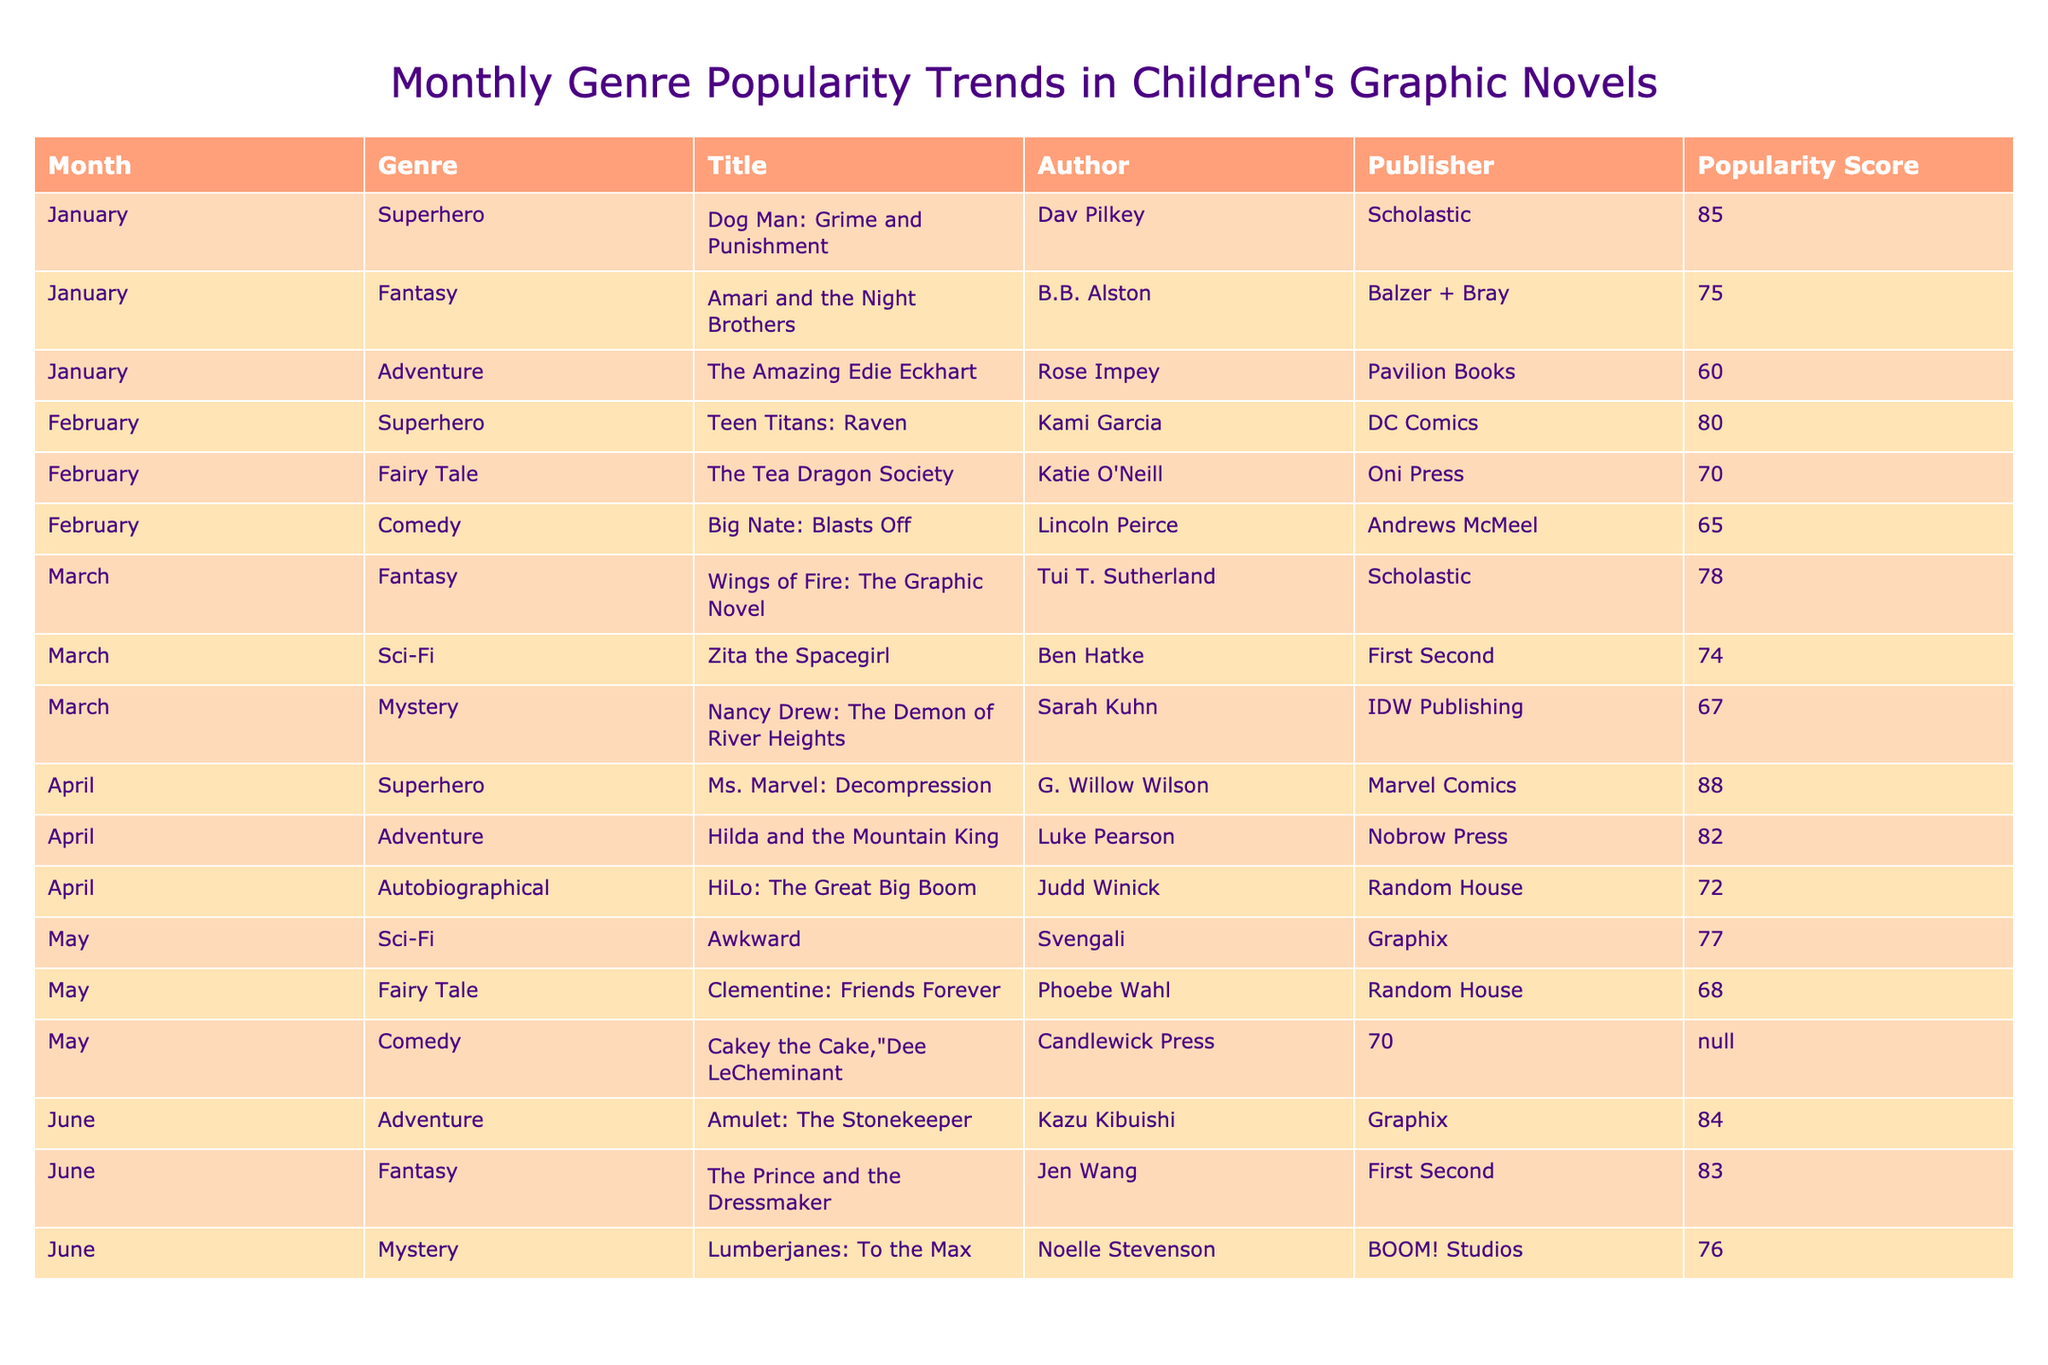What is the title of the most popular graphic novel in April? In the table, we look at the entries for April. The two entries with the highest popularity scores are "Ms. Marvel: Decompression" with a score of 88 and "Hilda and the Mountain King" with a score of 82. Since "Ms. Marvel: Decompression" has the highest score, that is the title we need.
Answer: Ms. Marvel: Decompression Which genre had the highest average popularity score across all months listed? First, we tally the popularity scores for each genre across all months. For example, the superhero genre has scores of 85 (January), 80 (February), 88 (April), totaling 253 for 3 titles. The fairy tale genre has scores of 75, 70, and 68, totaling 213 for 3 titles. By calculating the averages per genre, the superhero genre averages to 84.33 (253/3), while the others have lower averages. Thus, the superhero genre has the highest average score.
Answer: Superhero Was there a mystery graphic novel published in May? Checking the entries for May, the relevant genres listed are "Fairy Tale," "Comedy," and "Sci-Fi." There is no entry for the mystery genre in May, hence the answer is no.
Answer: No What was the total popularity score for Adventure genre titles across all months? We identify all entries in the Adventure genre. The titles include "The Amazing Edie Eckhart" with a score of 60, "Hilda and the Mountain King" with 82, and "Amulet: The Stonekeeper" with 84. Adding the scores, we find that 60 + 82 + 84 equals 226 for the Adventure genre.
Answer: 226 Which month had the lowest popularity score for Fantasy genre titles? We examine the entries for the Fantasy genre across all months. The scores are 75 for January, 78 for March, and 83 for June. The lowest among these is 75 in January, so that is the month we are looking for.
Answer: January How many different publishers produced titles in the Superhero genre? Looking at the table, we check which authors created superhero titles. The entries show "Dog Man: Grime and Punishment" by Scholastic, "Teen Titans: Raven" by DC Comics, and "Ms. Marvel: Decompression" by Marvel Comics. Thus, the number of different publishers is three.
Answer: 3 Which title had the lowest popularity score overall? Analyzing all the titles and their associated popularity scores, "The Amazing Edie Eckhart" has a popularity score of 60, which is the lowest among all titles listed in the table.
Answer: The Amazing Edie Eckhart Are there any titles published by Random House, and if so, which genre do they belong to? We can find entries from Random House within the table. "HiLo: The Great Big Boom" belongs to the Autobiographical genre, and "Clementine: Friends Forever" belongs to the Fairy Tale genre. Therefore, Random House has titles in both the Autobiographical and Fairy Tale genres.
Answer: Yes, Autobiographical and Fairy Tale 